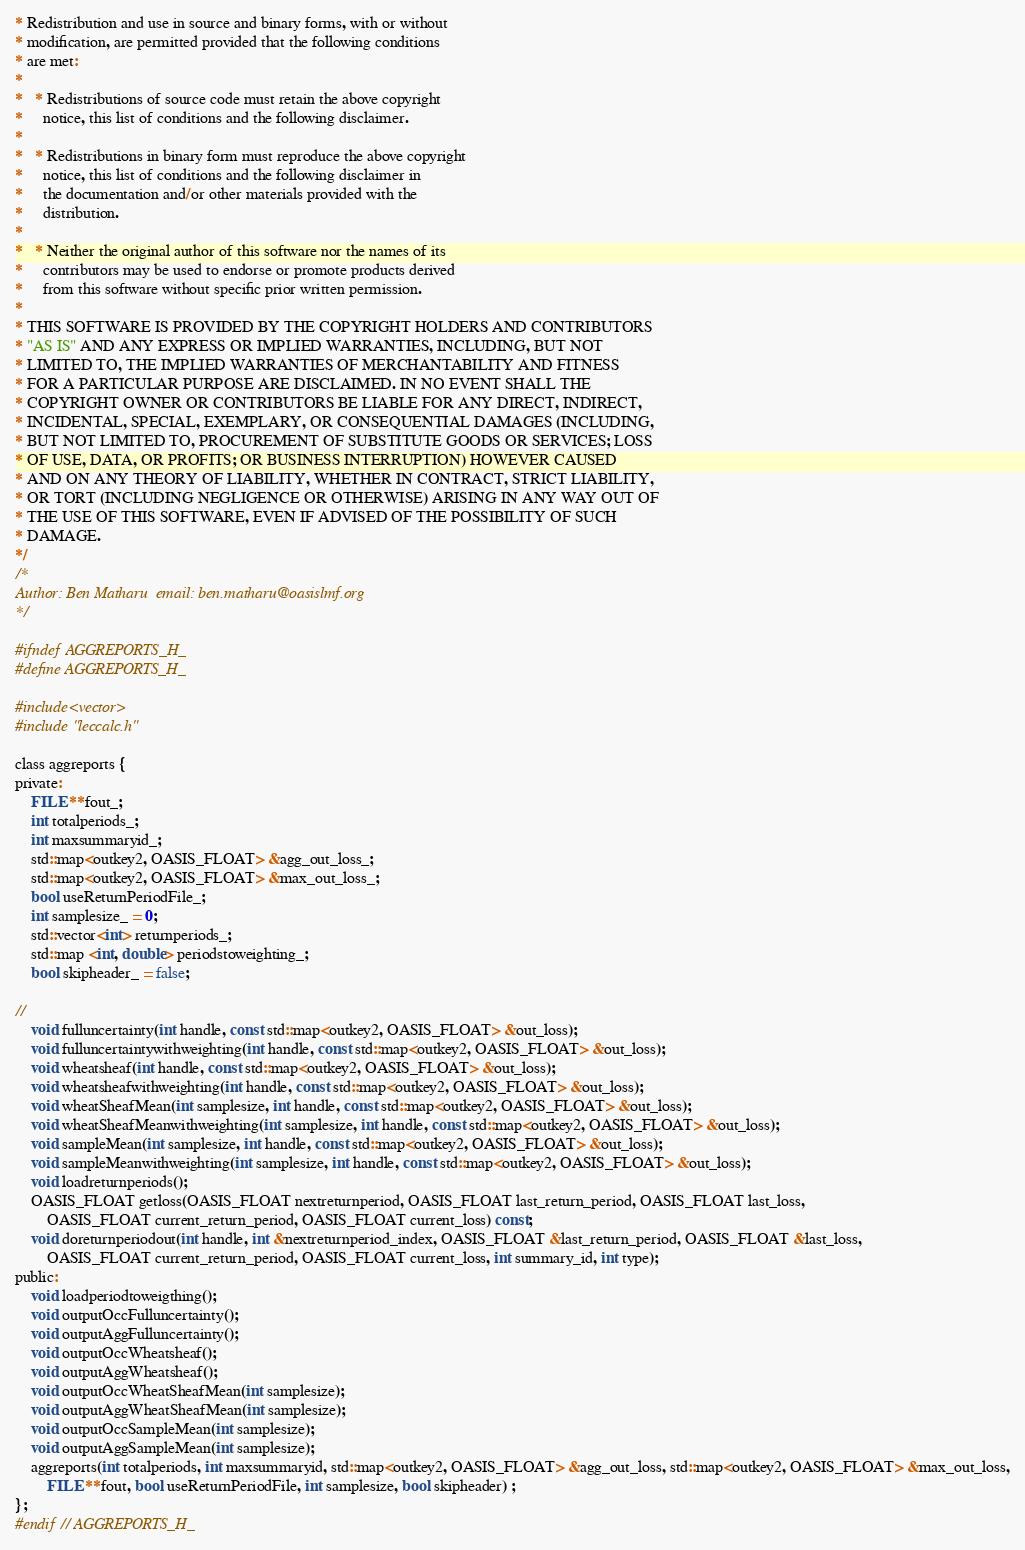Convert code to text. <code><loc_0><loc_0><loc_500><loc_500><_C_>* Redistribution and use in source and binary forms, with or without
* modification, are permitted provided that the following conditions
* are met:
*
*   * Redistributions of source code must retain the above copyright
*     notice, this list of conditions and the following disclaimer.
*
*   * Redistributions in binary form must reproduce the above copyright
*     notice, this list of conditions and the following disclaimer in
*     the documentation and/or other materials provided with the
*     distribution.
*
*   * Neither the original author of this software nor the names of its
*     contributors may be used to endorse or promote products derived
*     from this software without specific prior written permission.
*
* THIS SOFTWARE IS PROVIDED BY THE COPYRIGHT HOLDERS AND CONTRIBUTORS
* "AS IS" AND ANY EXPRESS OR IMPLIED WARRANTIES, INCLUDING, BUT NOT
* LIMITED TO, THE IMPLIED WARRANTIES OF MERCHANTABILITY AND FITNESS
* FOR A PARTICULAR PURPOSE ARE DISCLAIMED. IN NO EVENT SHALL THE
* COPYRIGHT OWNER OR CONTRIBUTORS BE LIABLE FOR ANY DIRECT, INDIRECT,
* INCIDENTAL, SPECIAL, EXEMPLARY, OR CONSEQUENTIAL DAMAGES (INCLUDING,
* BUT NOT LIMITED TO, PROCUREMENT OF SUBSTITUTE GOODS OR SERVICES; LOSS
* OF USE, DATA, OR PROFITS; OR BUSINESS INTERRUPTION) HOWEVER CAUSED
* AND ON ANY THEORY OF LIABILITY, WHETHER IN CONTRACT, STRICT LIABILITY,
* OR TORT (INCLUDING NEGLIGENCE OR OTHERWISE) ARISING IN ANY WAY OUT OF
* THE USE OF THIS SOFTWARE, EVEN IF ADVISED OF THE POSSIBILITY OF SUCH
* DAMAGE.
*/
/*
Author: Ben Matharu  email: ben.matharu@oasislmf.org
*/

#ifndef AGGREPORTS_H_
#define AGGREPORTS_H_

#include<vector>
#include "leccalc.h"

class aggreports {
private:
	FILE **fout_;
	int totalperiods_;
	int maxsummaryid_;
	std::map<outkey2, OASIS_FLOAT> &agg_out_loss_;
	std::map<outkey2, OASIS_FLOAT> &max_out_loss_;
	bool useReturnPeriodFile_;
	int samplesize_ = 0;
	std::vector<int> returnperiods_;
	std::map <int, double> periodstoweighting_;
	bool skipheader_ = false;

//
	void fulluncertainty(int handle, const std::map<outkey2, OASIS_FLOAT> &out_loss);	
	void fulluncertaintywithweighting(int handle, const std::map<outkey2, OASIS_FLOAT> &out_loss);
	void wheatsheaf(int handle, const std::map<outkey2, OASIS_FLOAT> &out_loss);
	void wheatsheafwithweighting(int handle, const std::map<outkey2, OASIS_FLOAT> &out_loss); 
	void wheatSheafMean(int samplesize, int handle, const std::map<outkey2, OASIS_FLOAT> &out_loss);	
	void wheatSheafMeanwithweighting(int samplesize, int handle, const std::map<outkey2, OASIS_FLOAT> &out_loss);
	void sampleMean(int samplesize, int handle, const std::map<outkey2, OASIS_FLOAT> &out_loss);
	void sampleMeanwithweighting(int samplesize, int handle, const std::map<outkey2, OASIS_FLOAT> &out_loss);
	void loadreturnperiods();
	OASIS_FLOAT getloss(OASIS_FLOAT nextreturnperiod, OASIS_FLOAT last_return_period, OASIS_FLOAT last_loss, 
		OASIS_FLOAT current_return_period, OASIS_FLOAT current_loss) const;
	void doreturnperiodout(int handle, int &nextreturnperiod_index, OASIS_FLOAT &last_return_period, OASIS_FLOAT &last_loss,
		OASIS_FLOAT current_return_period, OASIS_FLOAT current_loss, int summary_id, int type);
public:
	void loadperiodtoweigthing();
	void outputOccFulluncertainty();
	void outputAggFulluncertainty();
	void outputOccWheatsheaf();
	void outputAggWheatsheaf();
	void outputOccWheatSheafMean(int samplesize);
	void outputAggWheatSheafMean(int samplesize);
	void outputOccSampleMean(int samplesize);
	void outputAggSampleMean(int samplesize);
	aggreports(int totalperiods, int maxsummaryid, std::map<outkey2, OASIS_FLOAT> &agg_out_loss, std::map<outkey2, OASIS_FLOAT> &max_out_loss,
		FILE **fout, bool useReturnPeriodFile, int samplesize, bool skipheader) ;
};
#endif // AGGREPORTS_H_
</code> 